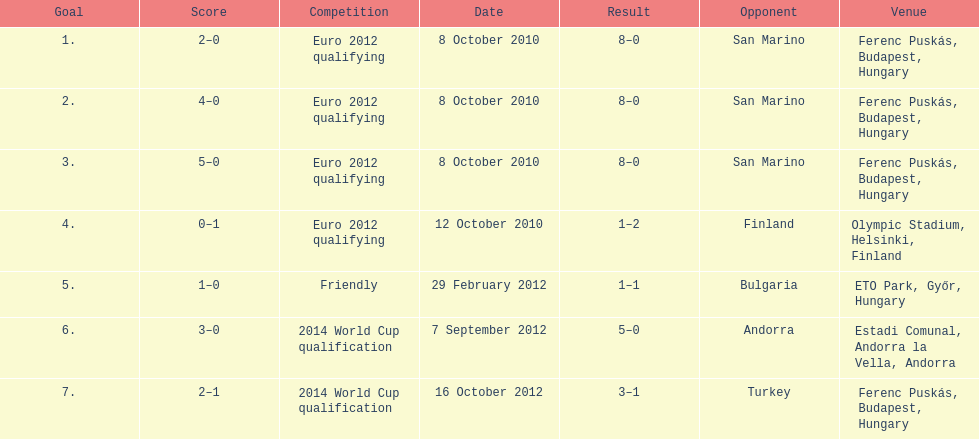Write the full table. {'header': ['Goal', 'Score', 'Competition', 'Date', 'Result', 'Opponent', 'Venue'], 'rows': [['1.', '2–0', 'Euro 2012 qualifying', '8 October 2010', '8–0', 'San Marino', 'Ferenc Puskás, Budapest, Hungary'], ['2.', '4–0', 'Euro 2012 qualifying', '8 October 2010', '8–0', 'San Marino', 'Ferenc Puskás, Budapest, Hungary'], ['3.', '5–0', 'Euro 2012 qualifying', '8 October 2010', '8–0', 'San Marino', 'Ferenc Puskás, Budapest, Hungary'], ['4.', '0–1', 'Euro 2012 qualifying', '12 October 2010', '1–2', 'Finland', 'Olympic Stadium, Helsinki, Finland'], ['5.', '1–0', 'Friendly', '29 February 2012', '1–1', 'Bulgaria', 'ETO Park, Győr, Hungary'], ['6.', '3–0', '2014 World Cup qualification', '7 September 2012', '5–0', 'Andorra', 'Estadi Comunal, Andorra la Vella, Andorra'], ['7.', '2–1', '2014 World Cup qualification', '16 October 2012', '3–1', 'Turkey', 'Ferenc Puskás, Budapest, Hungary']]} How many goals were netted in the euro 2012 qualifying contest? 12. 